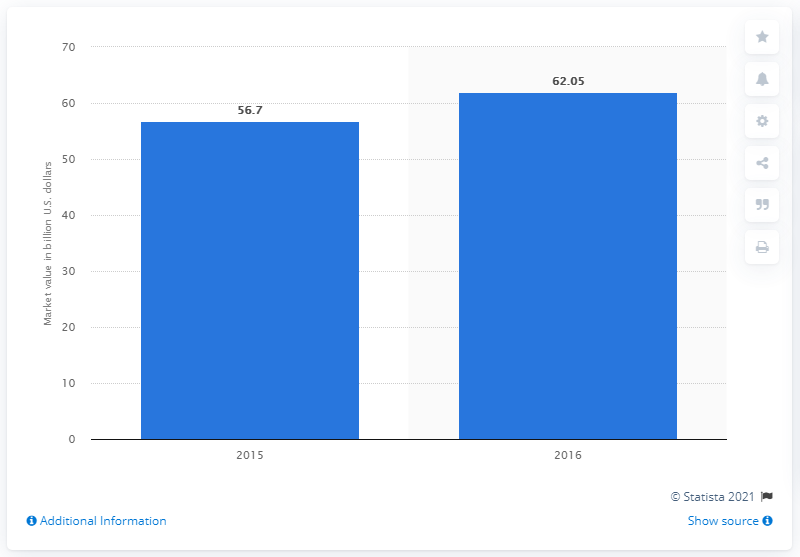Highlight a few significant elements in this photo. The global value of the technical ceramics market in 2016 was approximately $62.05 billion. 